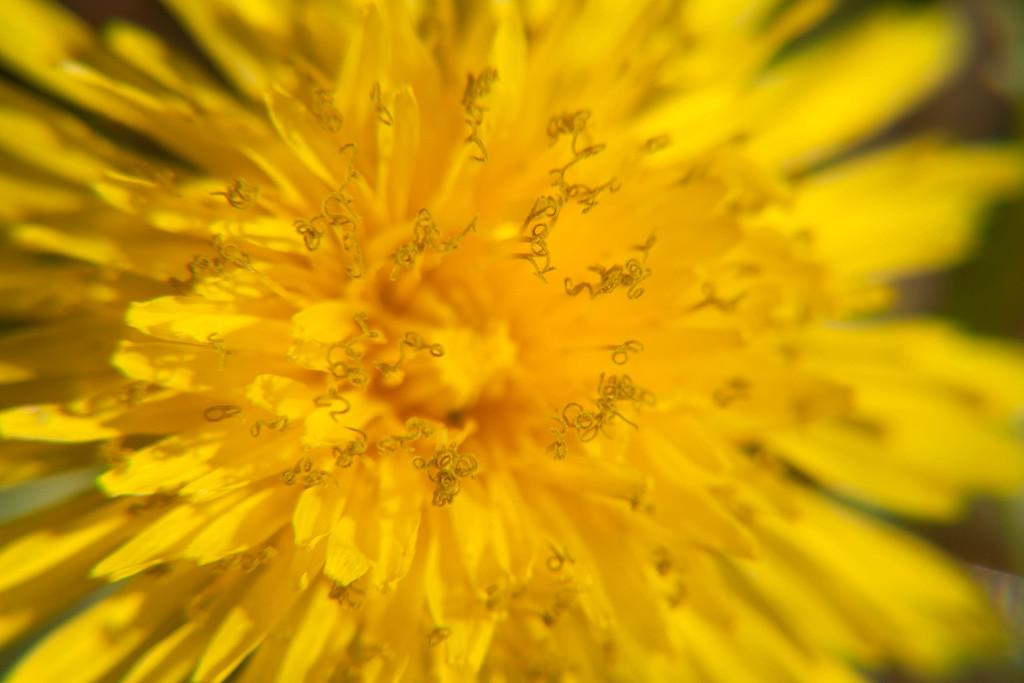What type of flower is present in the image? There is a yellow color flower in the image. What type of brake is used to stop the flower from growing in the image? There is no brake present in the image, as it is a photograph of a flower. 